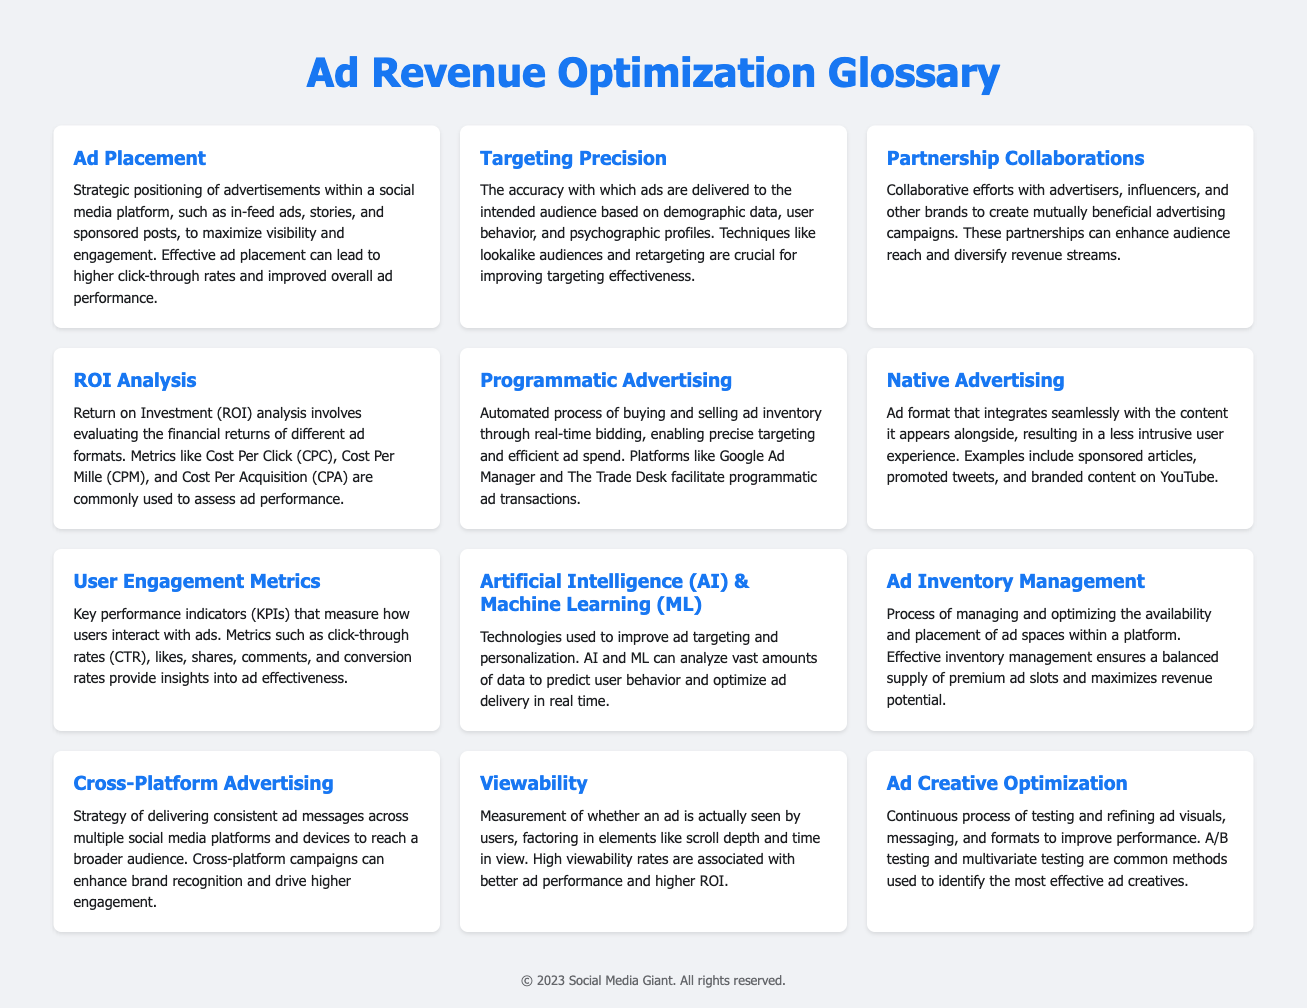What is Ad Placement? Ad Placement is defined as the strategic positioning of advertisements within a social media platform, aimed at maximizing visibility and engagement.
Answer: Strategic positioning of advertisements What does Targeting Precision refer to? Targeting Precision refers to the accuracy of ad delivery to the intended audience, utilizing demographic data and user behavior.
Answer: Accuracy of ad delivery What are User Engagement Metrics? User Engagement Metrics are key performance indicators that measure user interaction with ads.
Answer: Key performance indicators What is the purpose of ROI Analysis? The purpose of ROI Analysis is to evaluate the financial returns of different ad formats using metrics like CPC and CPM.
Answer: Evaluate financial returns What is Programmatic Advertising? Programmatic Advertising is the automated process of buying and selling ad inventory through real-time bidding.
Answer: Automated process of buying and selling ad inventory What role do Partnership Collaborations play? Partnership Collaborations involve collaborative efforts that enhance audience reach and diversify revenue streams.
Answer: Enhance audience reach What technologies improve ad targeting? Artificial Intelligence (AI) and Machine Learning (ML) are the technologies that enhance ad targeting and personalization.
Answer: AI and ML What is Ad Creative Optimization? Ad Creative Optimization is the continuous process of testing and refining ad visuals and messaging for improved performance.
Answer: Continuous process of testing and refining What does Viewability measure? Viewability measures whether an ad is actually seen by users, considering factors like scroll depth.
Answer: Whether an ad is actually seen 